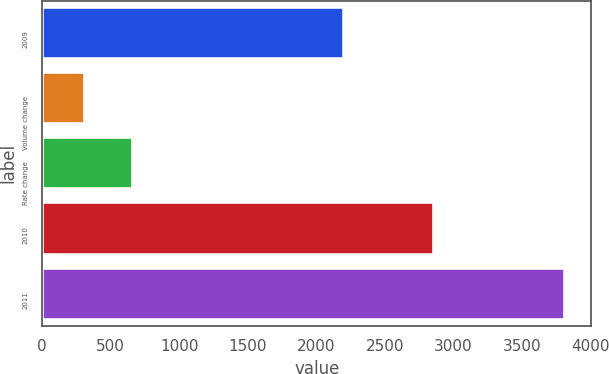Convert chart to OTSL. <chart><loc_0><loc_0><loc_500><loc_500><bar_chart><fcel>2009<fcel>Volume change<fcel>Rate change<fcel>2010<fcel>2011<nl><fcel>2202<fcel>317<fcel>666.7<fcel>2861<fcel>3814<nl></chart> 